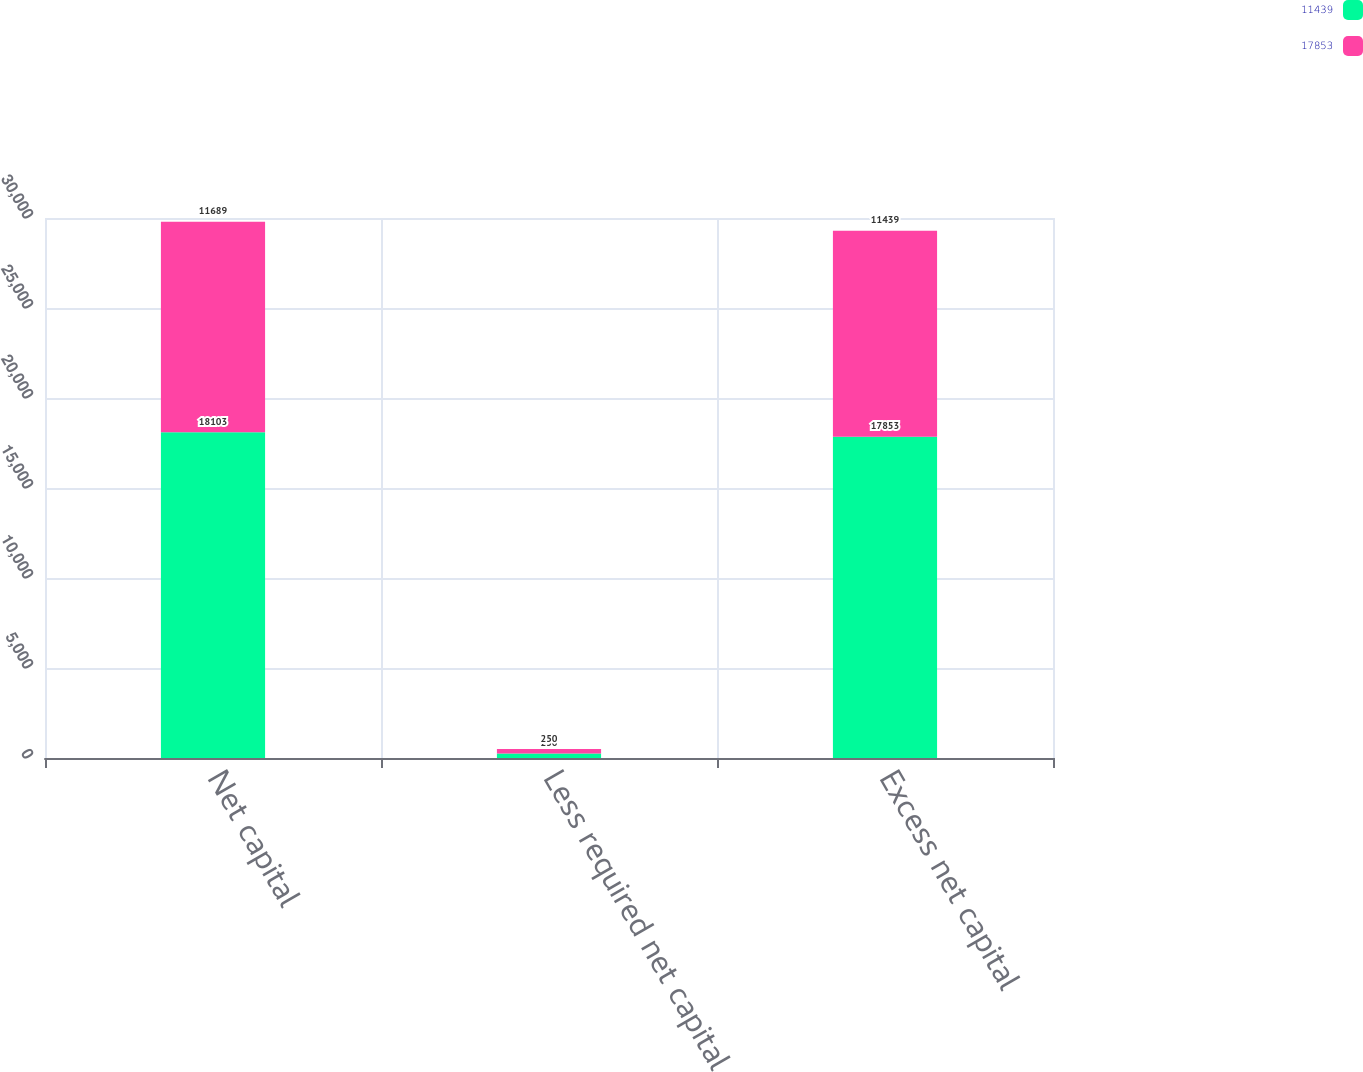Convert chart to OTSL. <chart><loc_0><loc_0><loc_500><loc_500><stacked_bar_chart><ecel><fcel>Net capital<fcel>Less required net capital<fcel>Excess net capital<nl><fcel>11439<fcel>18103<fcel>250<fcel>17853<nl><fcel>17853<fcel>11689<fcel>250<fcel>11439<nl></chart> 